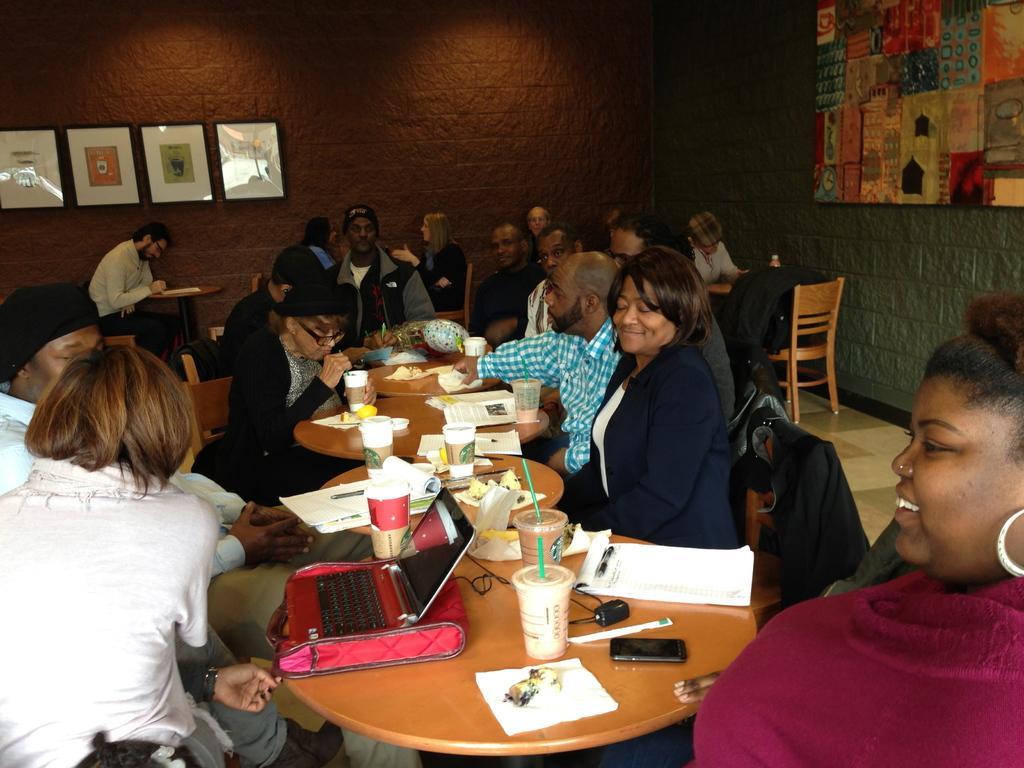In one or two sentences, can you explain what this image depicts? In the image we can see group of persons were sitting on the chair around the table,on table we can see some objects like bag,glass,paper,phone,pen etc. And back we can see wall and photo frames. 